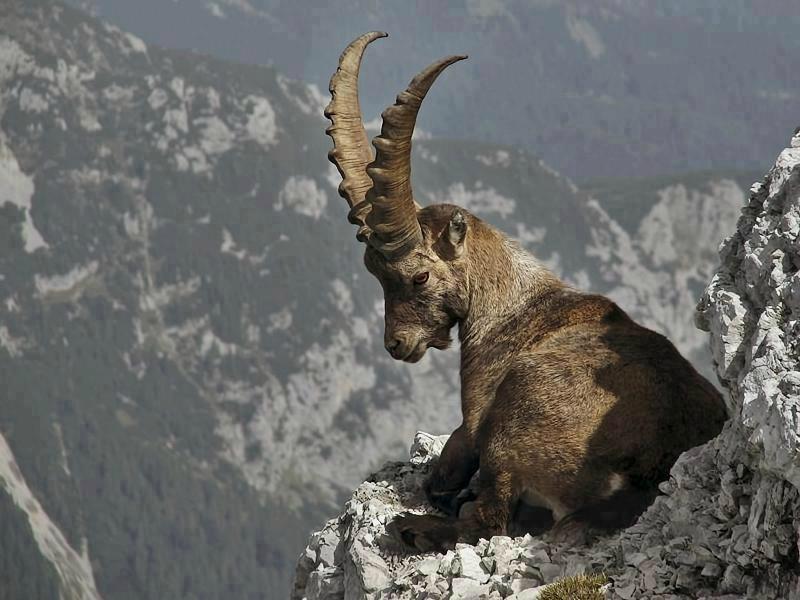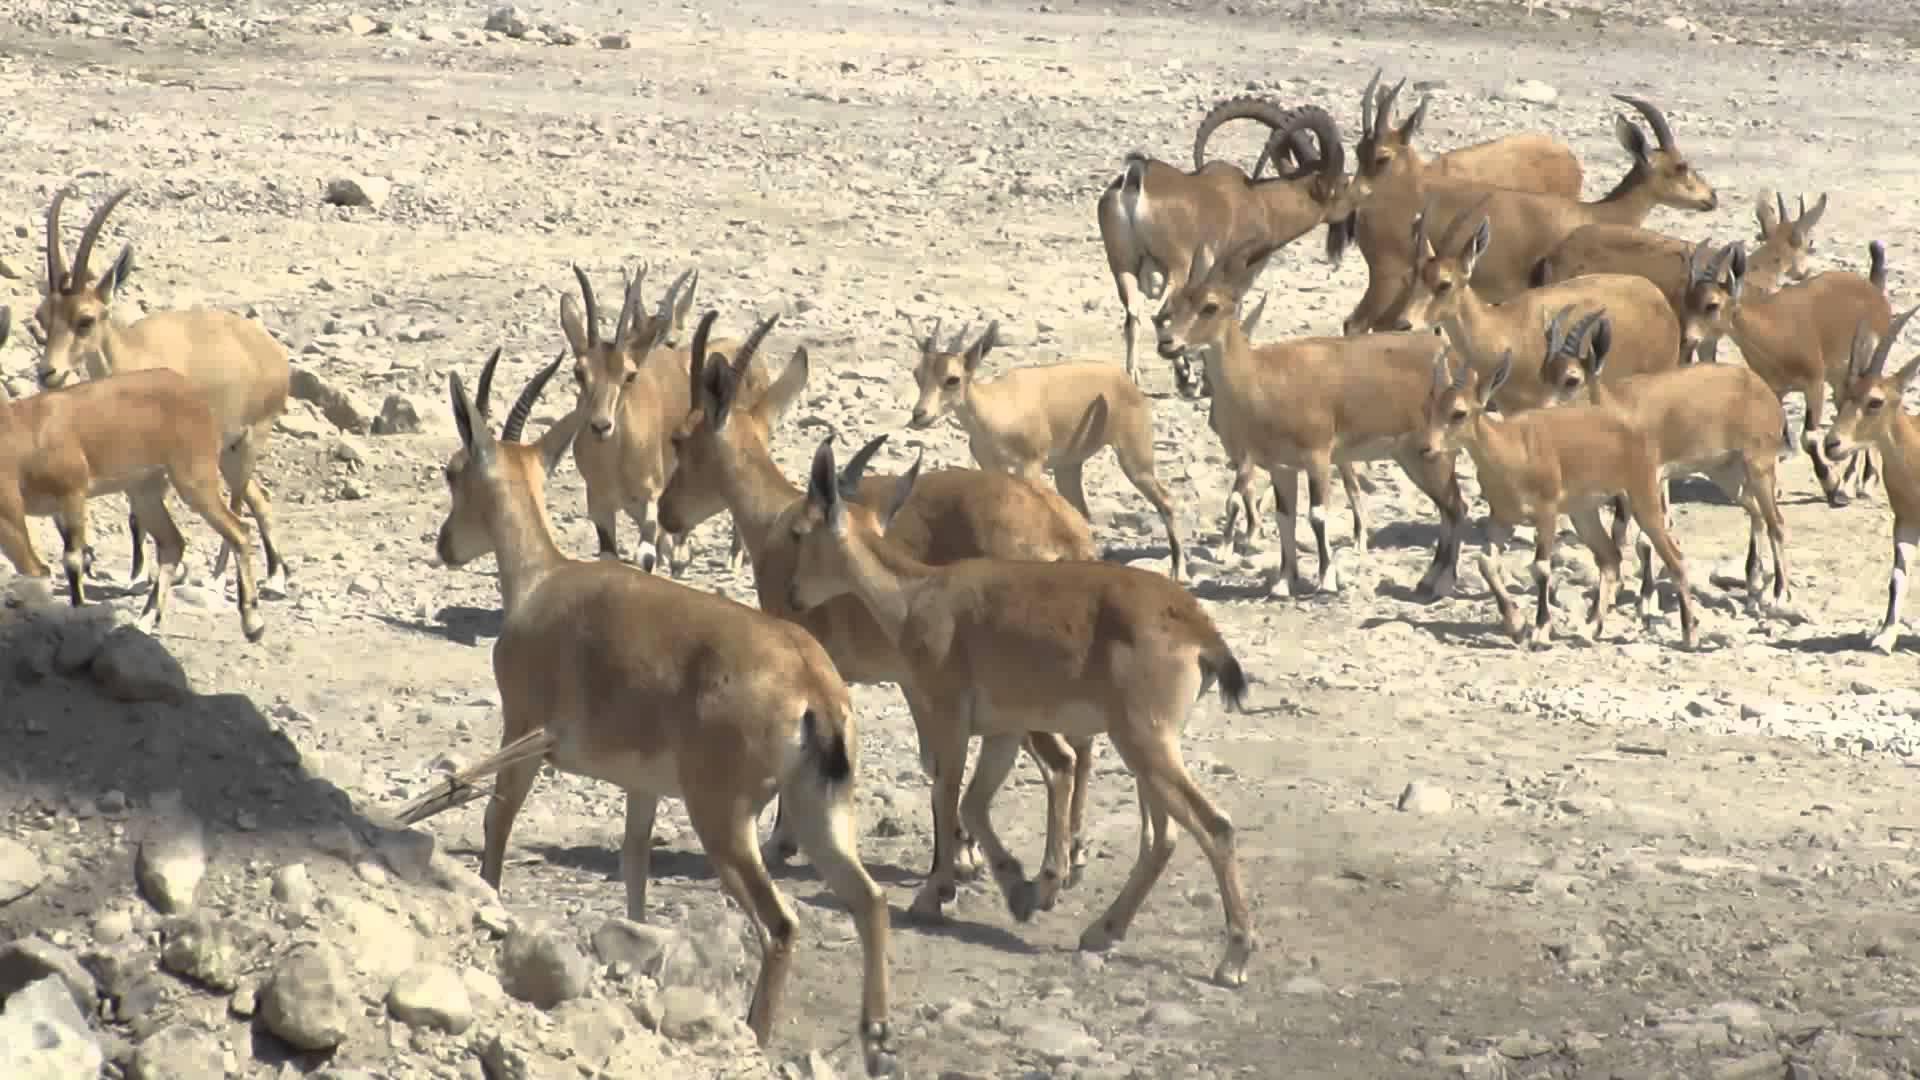The first image is the image on the left, the second image is the image on the right. For the images shown, is this caption "One picture only has one goat in it." true? Answer yes or no. Yes. The first image is the image on the left, the second image is the image on the right. Assess this claim about the two images: "One image has more than one but less than three mountain goats.". Correct or not? Answer yes or no. No. 